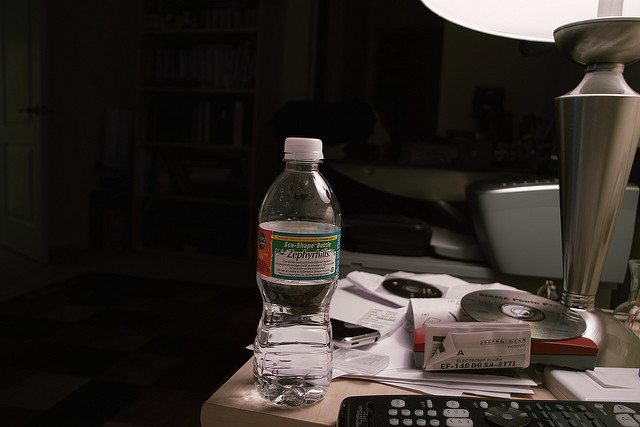Identify the text contained in this image. Zephyh Eco STTL A 